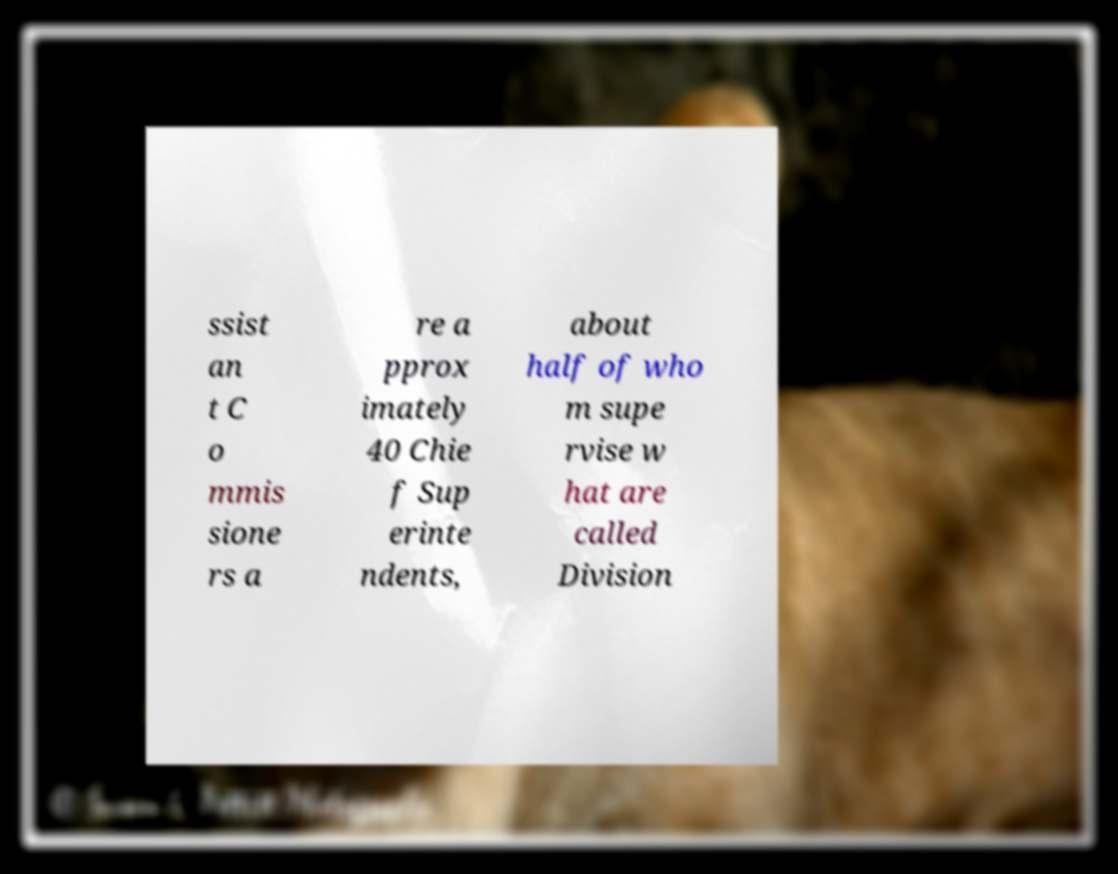Could you assist in decoding the text presented in this image and type it out clearly? ssist an t C o mmis sione rs a re a pprox imately 40 Chie f Sup erinte ndents, about half of who m supe rvise w hat are called Division 